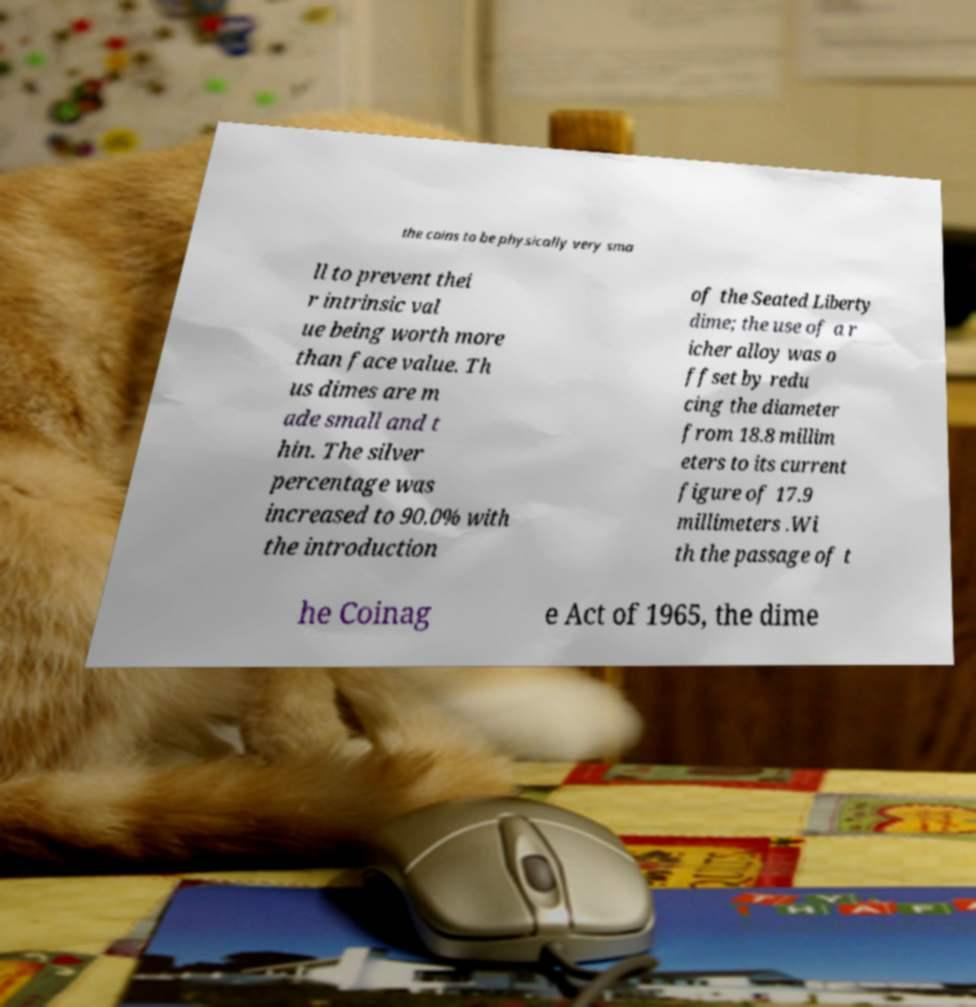There's text embedded in this image that I need extracted. Can you transcribe it verbatim? the coins to be physically very sma ll to prevent thei r intrinsic val ue being worth more than face value. Th us dimes are m ade small and t hin. The silver percentage was increased to 90.0% with the introduction of the Seated Liberty dime; the use of a r icher alloy was o ffset by redu cing the diameter from 18.8 millim eters to its current figure of 17.9 millimeters .Wi th the passage of t he Coinag e Act of 1965, the dime 